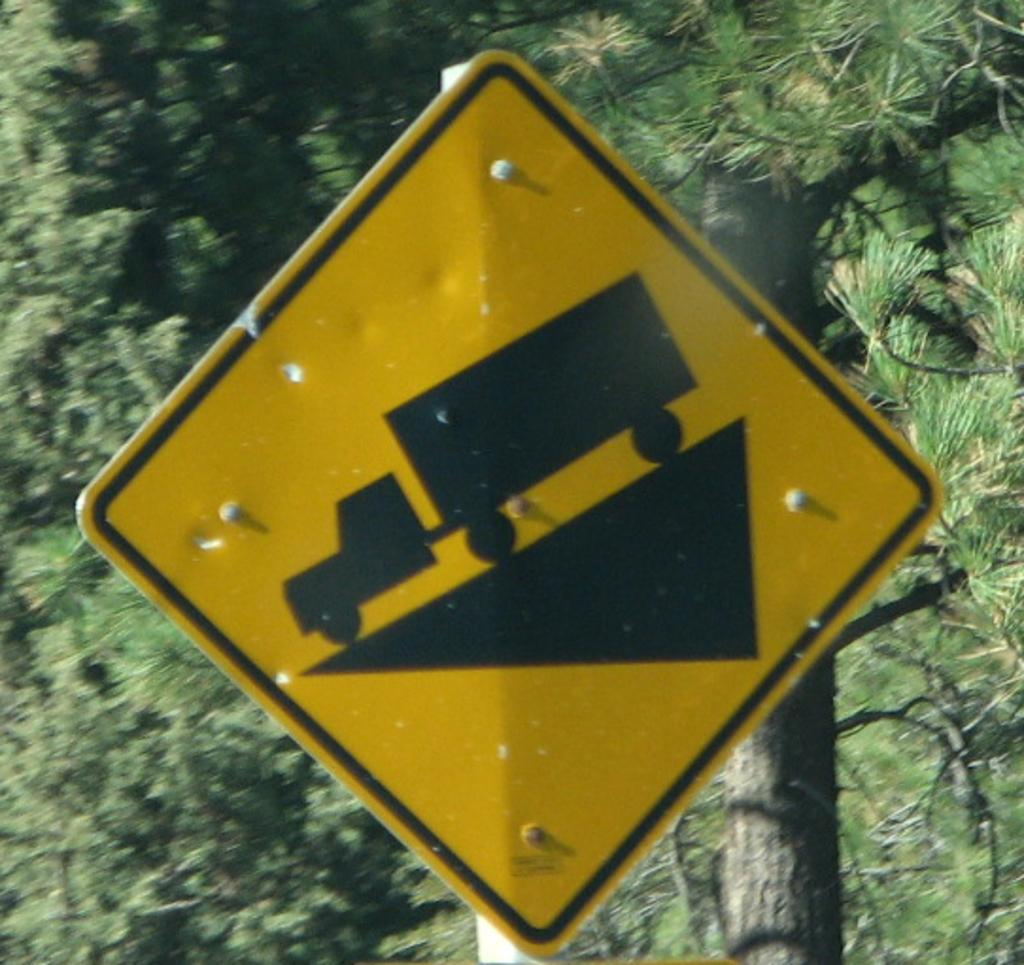What is the main object in the image? There is a board on a pole in the image. What can be seen in the background of the image? There are trees visible in the background of the image. What type of drum can be heard playing in the image? There is no drum present in the image, and therefore no sound can be heard. 